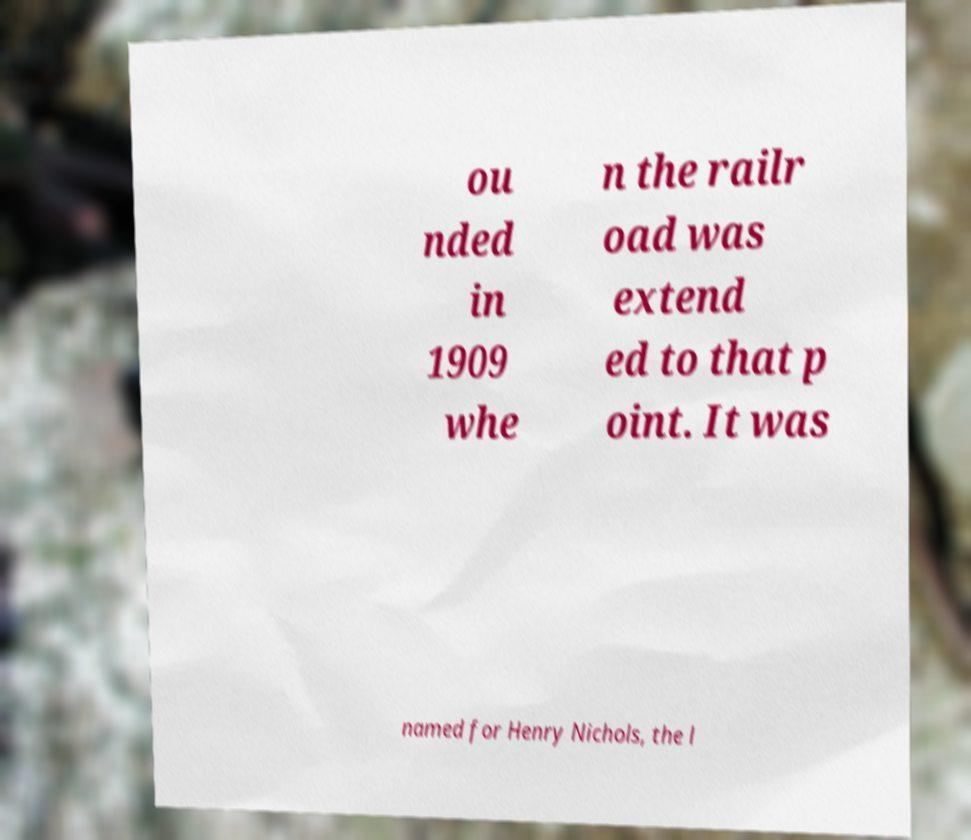Please identify and transcribe the text found in this image. ou nded in 1909 whe n the railr oad was extend ed to that p oint. It was named for Henry Nichols, the l 